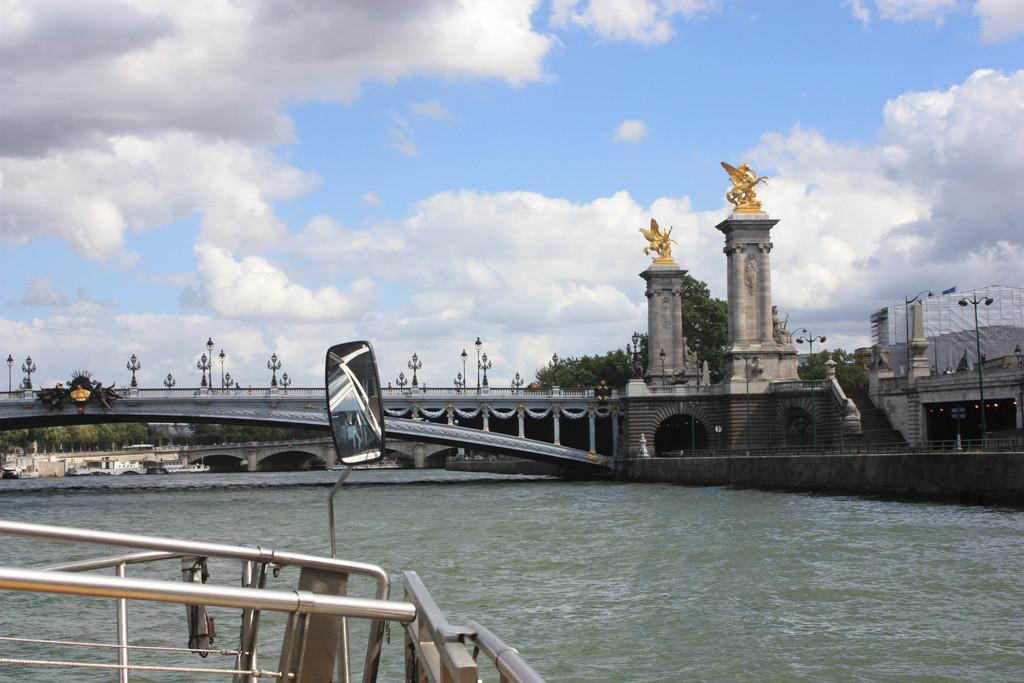Describe this image in one or two sentences. In this image we can see a bridge placed on top of the water. To the left side of the image we can see a mirror attached to group of poles. In the background, we can see a group of trees,poles, and a cloudy sky. 